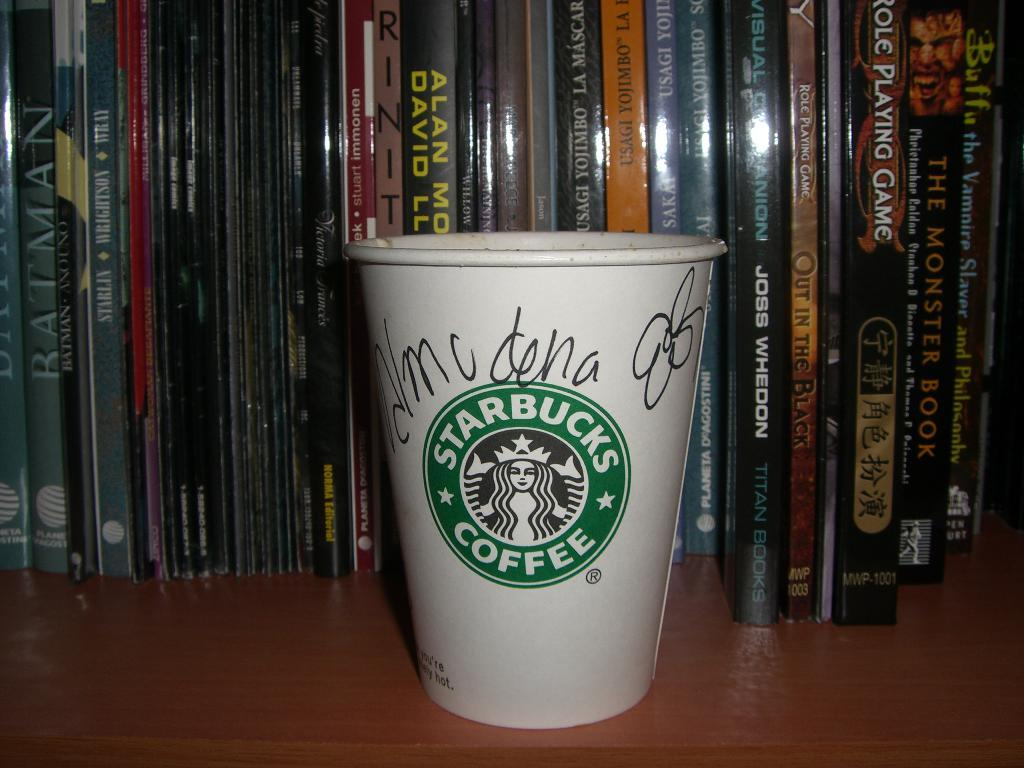<image>
Write a terse but informative summary of the picture. A coffee cup with a green label, in the label it says Starbucks. 